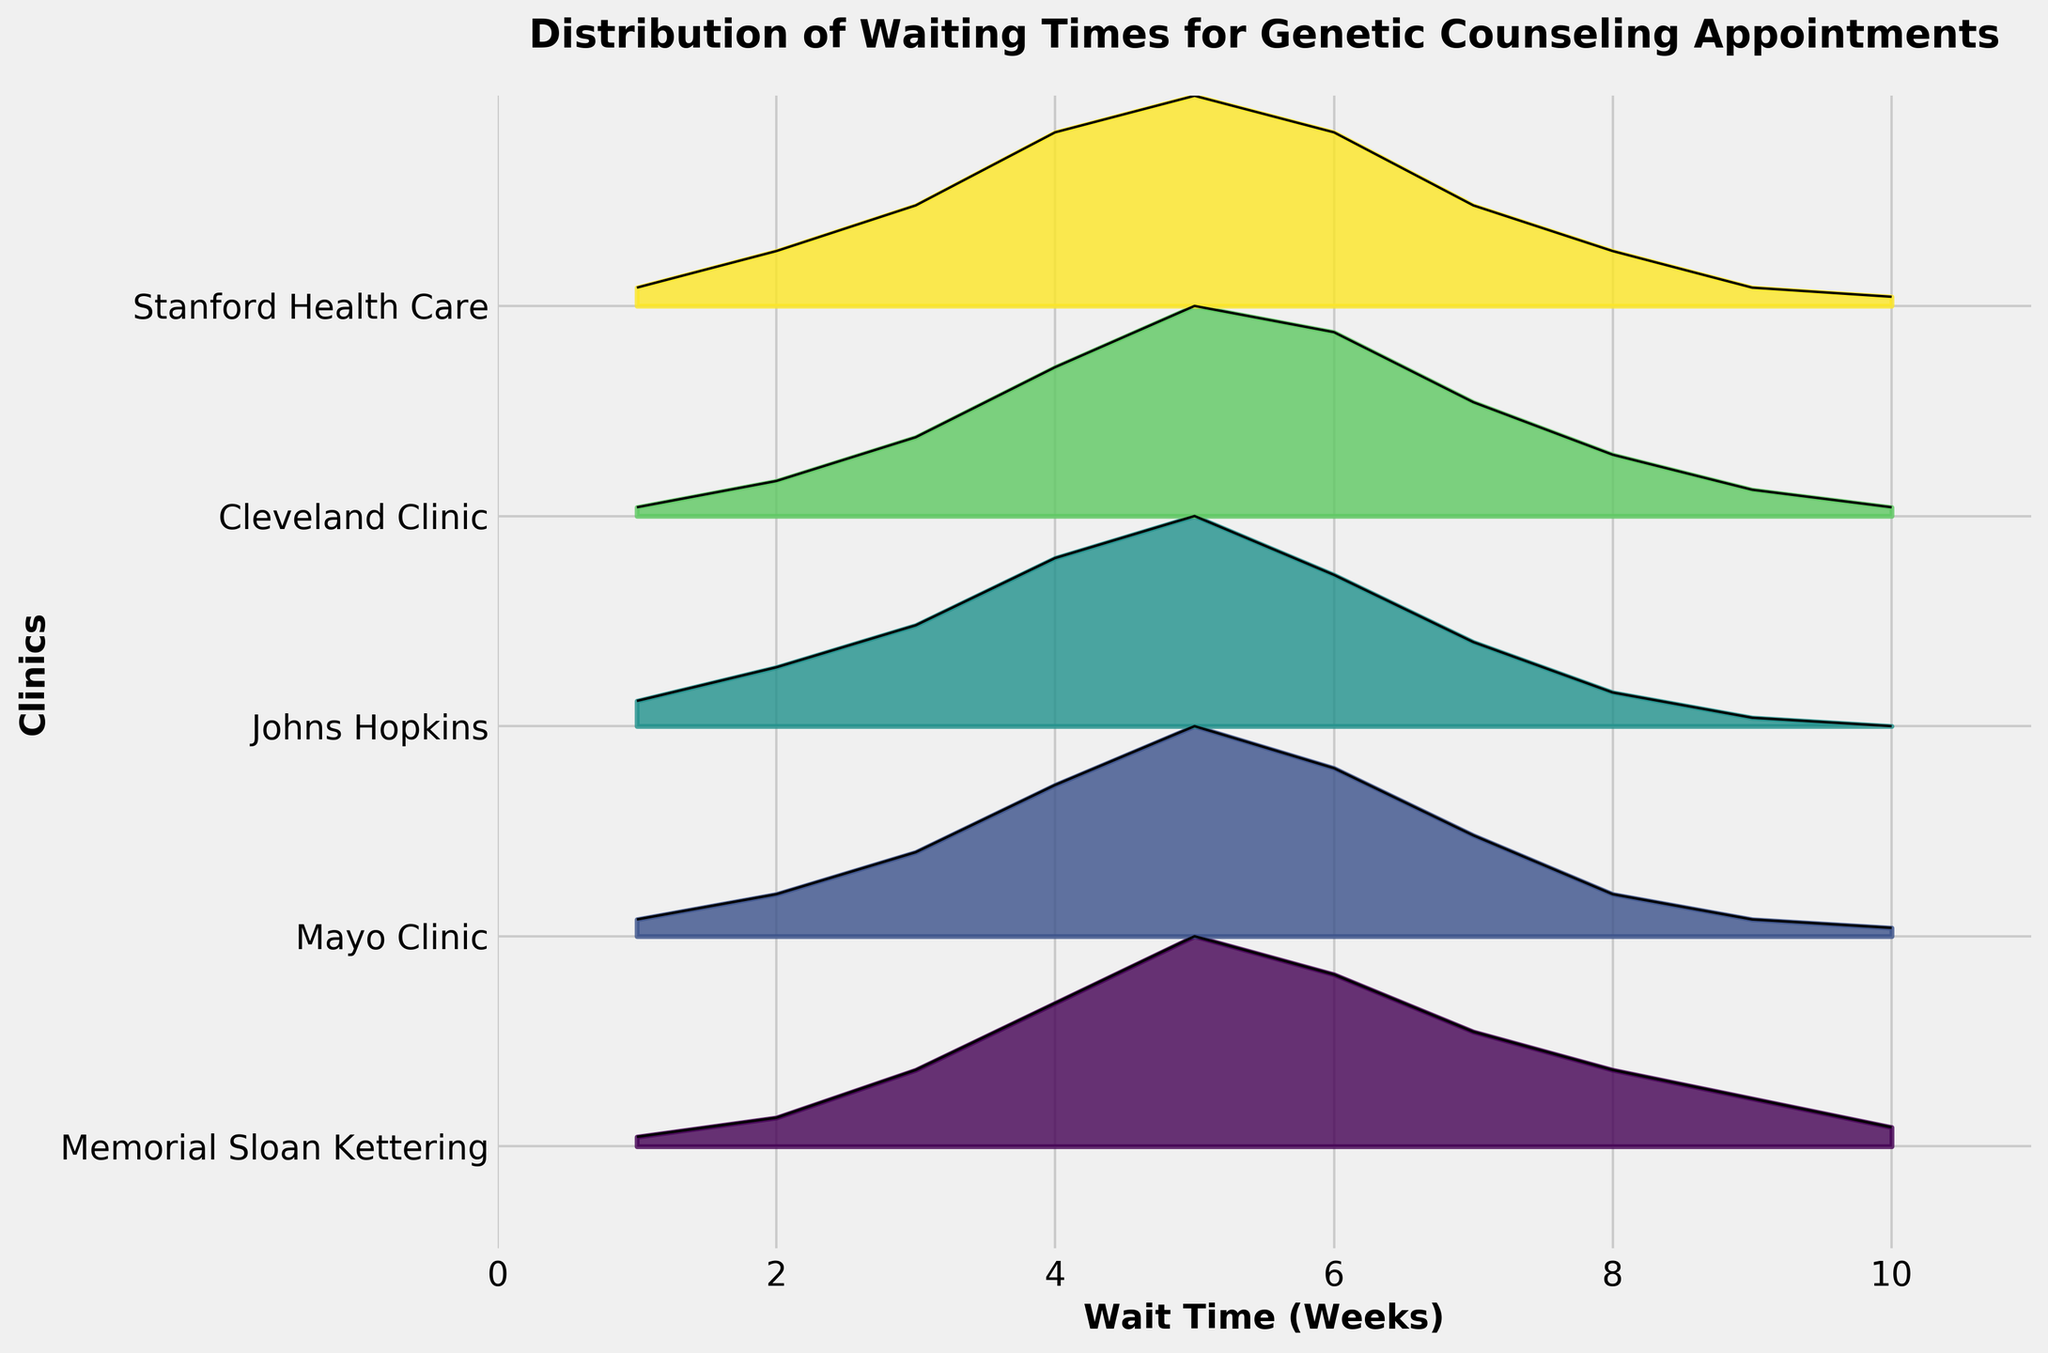What is the clinic with the highest density for a 5-week waiting time? By observing the peak values for a 5-week waiting time in the plot, the highest density should be compared among the clinics. From the figure, the Mayo Clinic reaches a density of 0.25 at 5 weeks, which is higher than others.
Answer: Mayo Clinic Which clinic has the widest distribution of waiting times? A wider distribution in a Ridgeline plot would have its curve spread out more along the x-axis, indicating a larger range of waiting times. All clinics span from 1 to 10 weeks, but emphasis on distribution width can be judged.
Answer: All have similar width What is the peak density for Johns Hopkins? Referring to how tall the curve gets for Johns Hopkins specifically, the highest peak indicates the maximum density. The peak density of Johns Hopkins is 0.25.
Answer: 0.25 Which clinic's wait time distribution has the sharpest decline after the peak? After peaking, a sharp decline means a steep drop in density. By observing the declining side of the peaks, it appears Johns Hopkins has a quick drop after its peak at 5 weeks.
Answer: Johns Hopkins How do the waiting times for Memorial Sloan Kettering compare to Mayo Clinic? Comparing the density distributions side by side, Memorial Sloan Kettering peaks slightly earlier and has a shorter tail compared to the Mayo Clinic. Both have peaks around 4-5 weeks.
Answer: Less wide, peaks earlier What is the average wait time for Stanford Health Care? For an average, consider the weeks weighted by their densities. Stanford has a peak at 5 but significant spread both sides, predominantly between 3-7 weeks. With densest regions in mid-range, it's close to the middle.
Answer: Around 5 weeks Which clinic has the lowest density for a 10-week waiting time? Checking 10-week mark on the x-axis for each clinic's density. Johns Hopkins has density dropping to 0 at this point.
Answer: Johns Hopkins How do the wait times for Cleveland Clinic compare to Stanford Health Care? Observe the heights and spread; both have similar spread and shape but Cleveland shows a higher density peak around 5 weeks and a slight shift leftward.
Answer: Cleveland is denser around 5 weeks What is the unique characteristic of the Ridgeline plot shown? Identify chart-type specific aspects: a Ridgeline plot shows multiple density plots for different groups stacked vertically, emphasizing distribution spread over just numeric summaries.
Answer: Shows distribution vividly Which clinic has the most balanced distribution considering symmetry around its peak? Balanced distribution would look more symmetrical around the highest density. Observing symmetry, Cleveland Clinic shows high density balance flanking 5-week peak.
Answer: Cleveland Clinic 